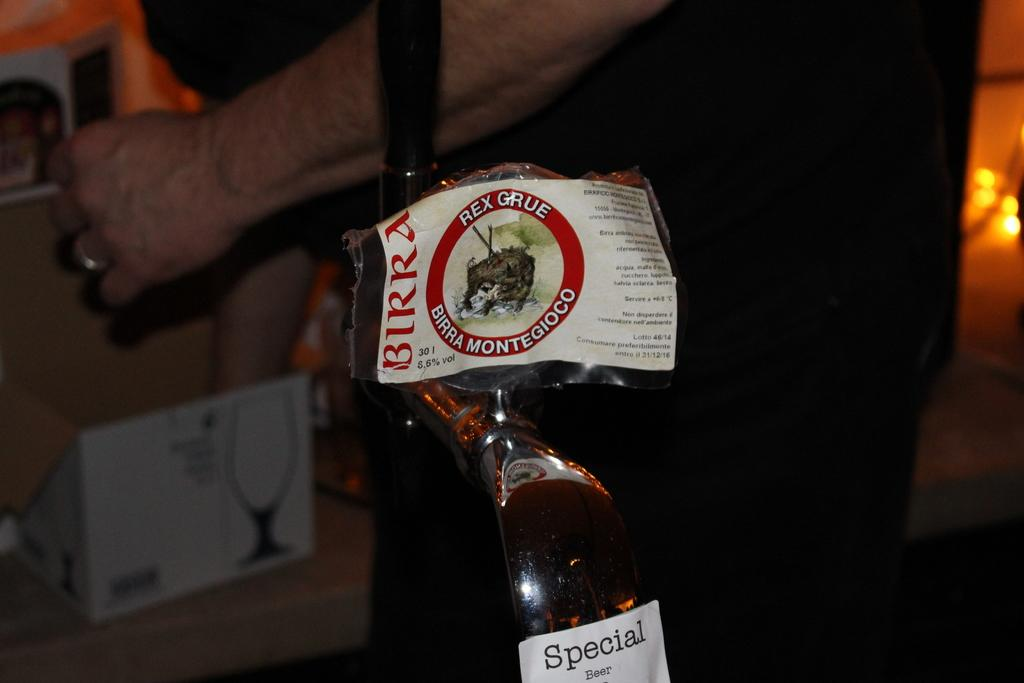Provide a one-sentence caption for the provided image. A person is standing behind a tap that has a while label that says Special Beer. 